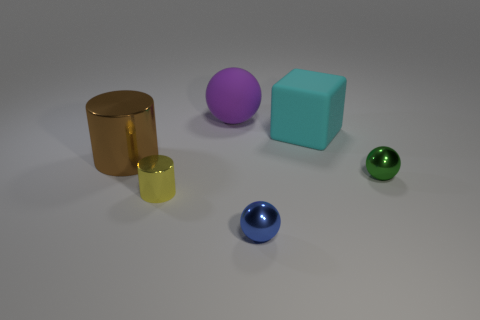Subtract 1 cubes. How many cubes are left? 0 Add 3 big brown metallic cylinders. How many objects exist? 9 Subtract all large spheres. How many spheres are left? 2 Subtract 1 yellow cylinders. How many objects are left? 5 Subtract all cubes. How many objects are left? 5 Subtract all cyan spheres. Subtract all blue cylinders. How many spheres are left? 3 Subtract all cyan cubes. How many brown cylinders are left? 1 Subtract all gray cylinders. Subtract all small yellow metallic things. How many objects are left? 5 Add 4 yellow things. How many yellow things are left? 5 Add 2 small red metal objects. How many small red metal objects exist? 2 